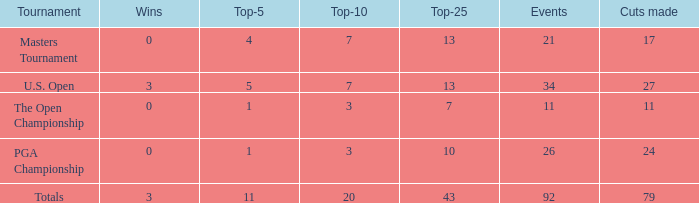Name the tournament for top-5 more thn 1 and top-25 of 13 with wins of 3 U.S. Open. 